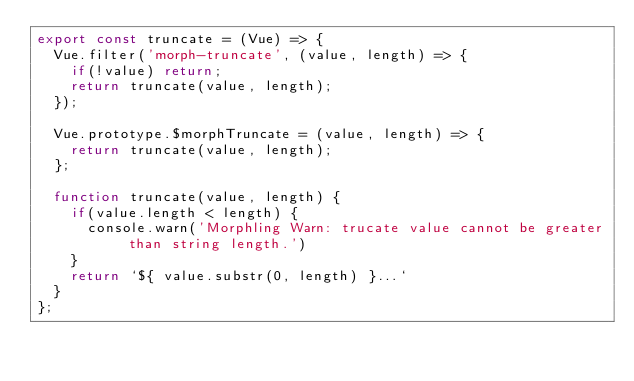<code> <loc_0><loc_0><loc_500><loc_500><_JavaScript_>export const truncate = (Vue) => {
  Vue.filter('morph-truncate', (value, length) => {
    if(!value) return;
    return truncate(value, length);
  });

  Vue.prototype.$morphTruncate = (value, length) => {
    return truncate(value, length);
  };

  function truncate(value, length) {
    if(value.length < length) {
      console.warn('Morphling Warn: trucate value cannot be greater than string length.')
    }
    return `${ value.substr(0, length) }...`
  }
};</code> 